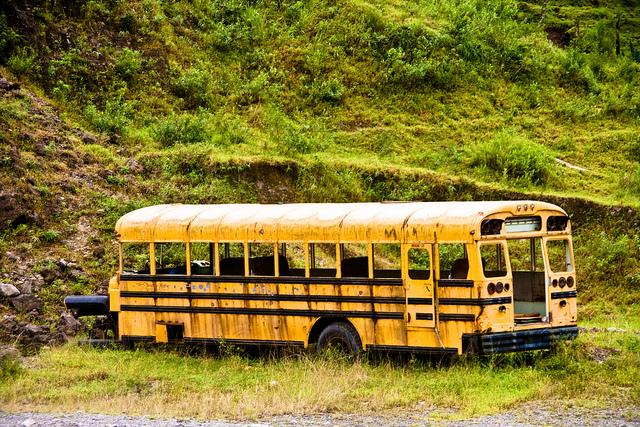Are there people on the bus?
Be succinct. No. Is the bus functional?
Keep it brief. No. Is there a door on the back of the bus?
Be succinct. No. 